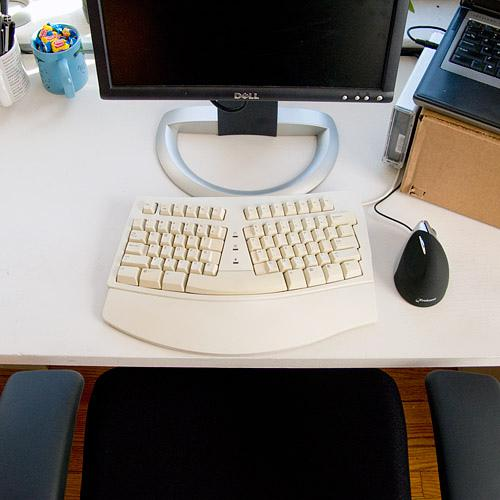Question: why would you use this machine?
Choices:
A. Plot world domination.
B. Build a house.
C. Preform surgery.
D. Surf internet.
Answer with the letter. Answer: D Question: what color is the cup?
Choices:
A. Green.
B. Black.
C. White.
D. Blue.
Answer with the letter. Answer: D Question: how do you type on this machine?
Choices:
A. Remote control.
B. Steering wheel.
C. Keyboard.
D. Bicycle.
Answer with the letter. Answer: C Question: what type of monitor does he have?
Choices:
A. Gateway.
B. Sony.
C. Apple.
D. Dell.
Answer with the letter. Answer: D Question: where do you sit to use the machine?
Choices:
A. Beside it.
B. In front of it.
C. At the desk.
D. On a stool.
Answer with the letter. Answer: B 